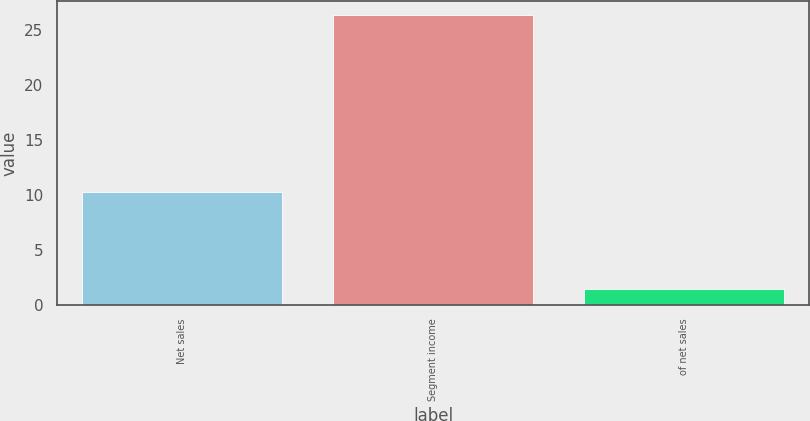Convert chart to OTSL. <chart><loc_0><loc_0><loc_500><loc_500><bar_chart><fcel>Net sales<fcel>Segment income<fcel>of net sales<nl><fcel>10.3<fcel>26.4<fcel>1.5<nl></chart> 